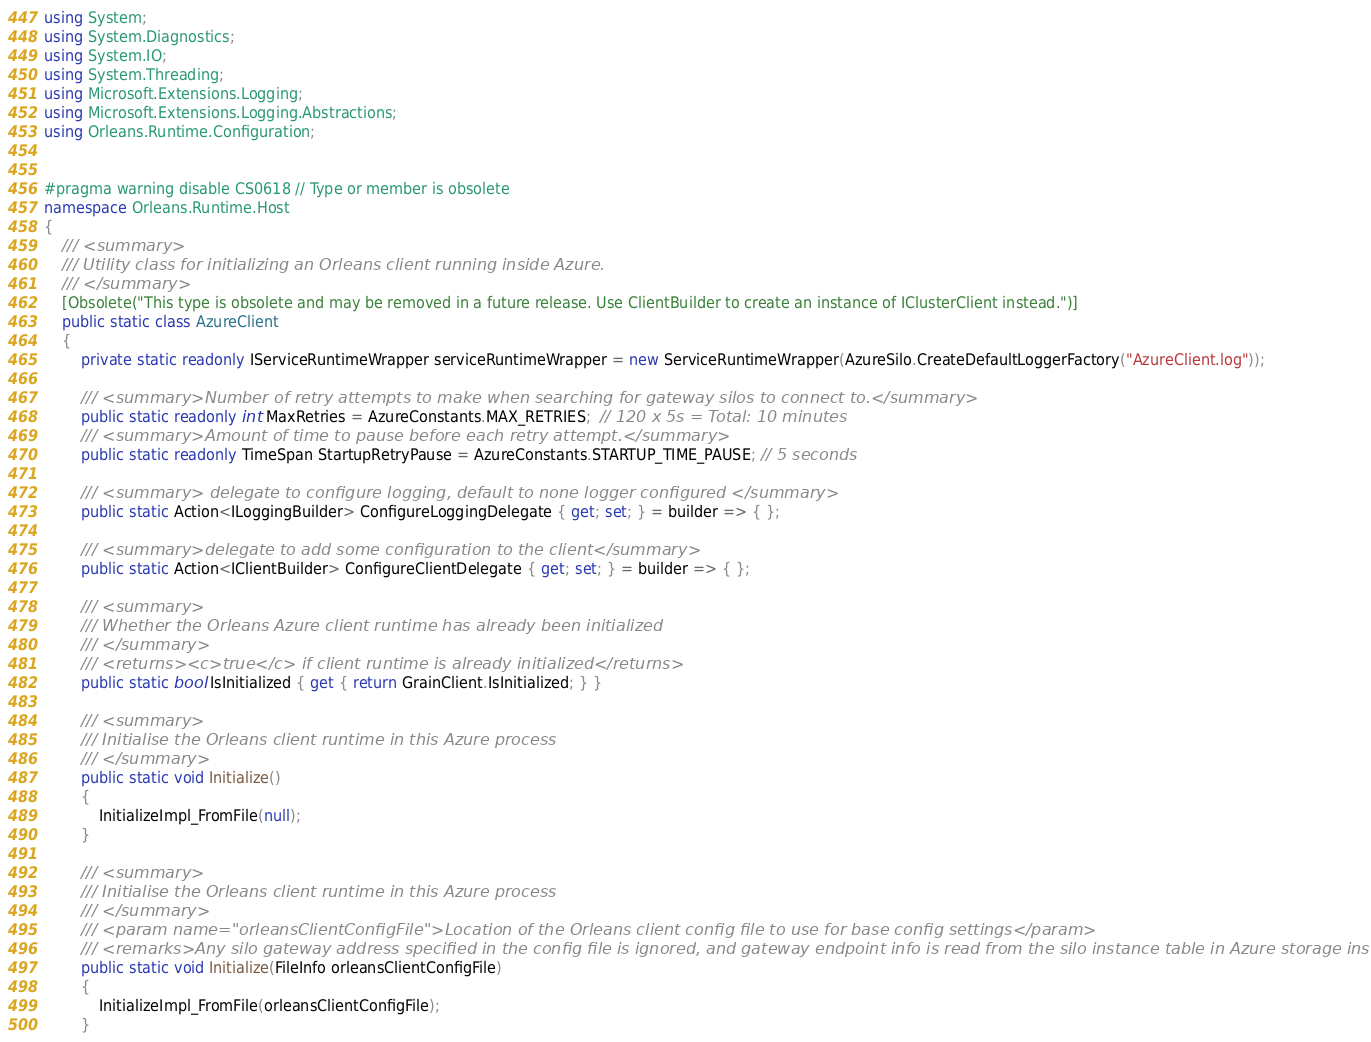<code> <loc_0><loc_0><loc_500><loc_500><_C#_>using System;
using System.Diagnostics;
using System.IO;
using System.Threading;
using Microsoft.Extensions.Logging;
using Microsoft.Extensions.Logging.Abstractions;
using Orleans.Runtime.Configuration;


#pragma warning disable CS0618 // Type or member is obsolete
namespace Orleans.Runtime.Host
{
    /// <summary>
    /// Utility class for initializing an Orleans client running inside Azure.
    /// </summary>
    [Obsolete("This type is obsolete and may be removed in a future release. Use ClientBuilder to create an instance of IClusterClient instead.")]
    public static class AzureClient
    {
        private static readonly IServiceRuntimeWrapper serviceRuntimeWrapper = new ServiceRuntimeWrapper(AzureSilo.CreateDefaultLoggerFactory("AzureClient.log"));

        /// <summary>Number of retry attempts to make when searching for gateway silos to connect to.</summary>
        public static readonly int MaxRetries = AzureConstants.MAX_RETRIES;  // 120 x 5s = Total: 10 minutes
        /// <summary>Amount of time to pause before each retry attempt.</summary>
        public static readonly TimeSpan StartupRetryPause = AzureConstants.STARTUP_TIME_PAUSE; // 5 seconds

        /// <summary> delegate to configure logging, default to none logger configured </summary>
        public static Action<ILoggingBuilder> ConfigureLoggingDelegate { get; set; } = builder => { };

        /// <summary>delegate to add some configuration to the client</summary>
        public static Action<IClientBuilder> ConfigureClientDelegate { get; set; } = builder => { };

        /// <summary>
        /// Whether the Orleans Azure client runtime has already been initialized
        /// </summary>
        /// <returns><c>true</c> if client runtime is already initialized</returns>
        public static bool IsInitialized { get { return GrainClient.IsInitialized; } }

        /// <summary>
        /// Initialise the Orleans client runtime in this Azure process
        /// </summary>
        public static void Initialize()
        {
            InitializeImpl_FromFile(null);
        }

        /// <summary>
        /// Initialise the Orleans client runtime in this Azure process
        /// </summary>
        /// <param name="orleansClientConfigFile">Location of the Orleans client config file to use for base config settings</param>
        /// <remarks>Any silo gateway address specified in the config file is ignored, and gateway endpoint info is read from the silo instance table in Azure storage instead.</remarks>
        public static void Initialize(FileInfo orleansClientConfigFile)
        {
            InitializeImpl_FromFile(orleansClientConfigFile);
        }
</code> 